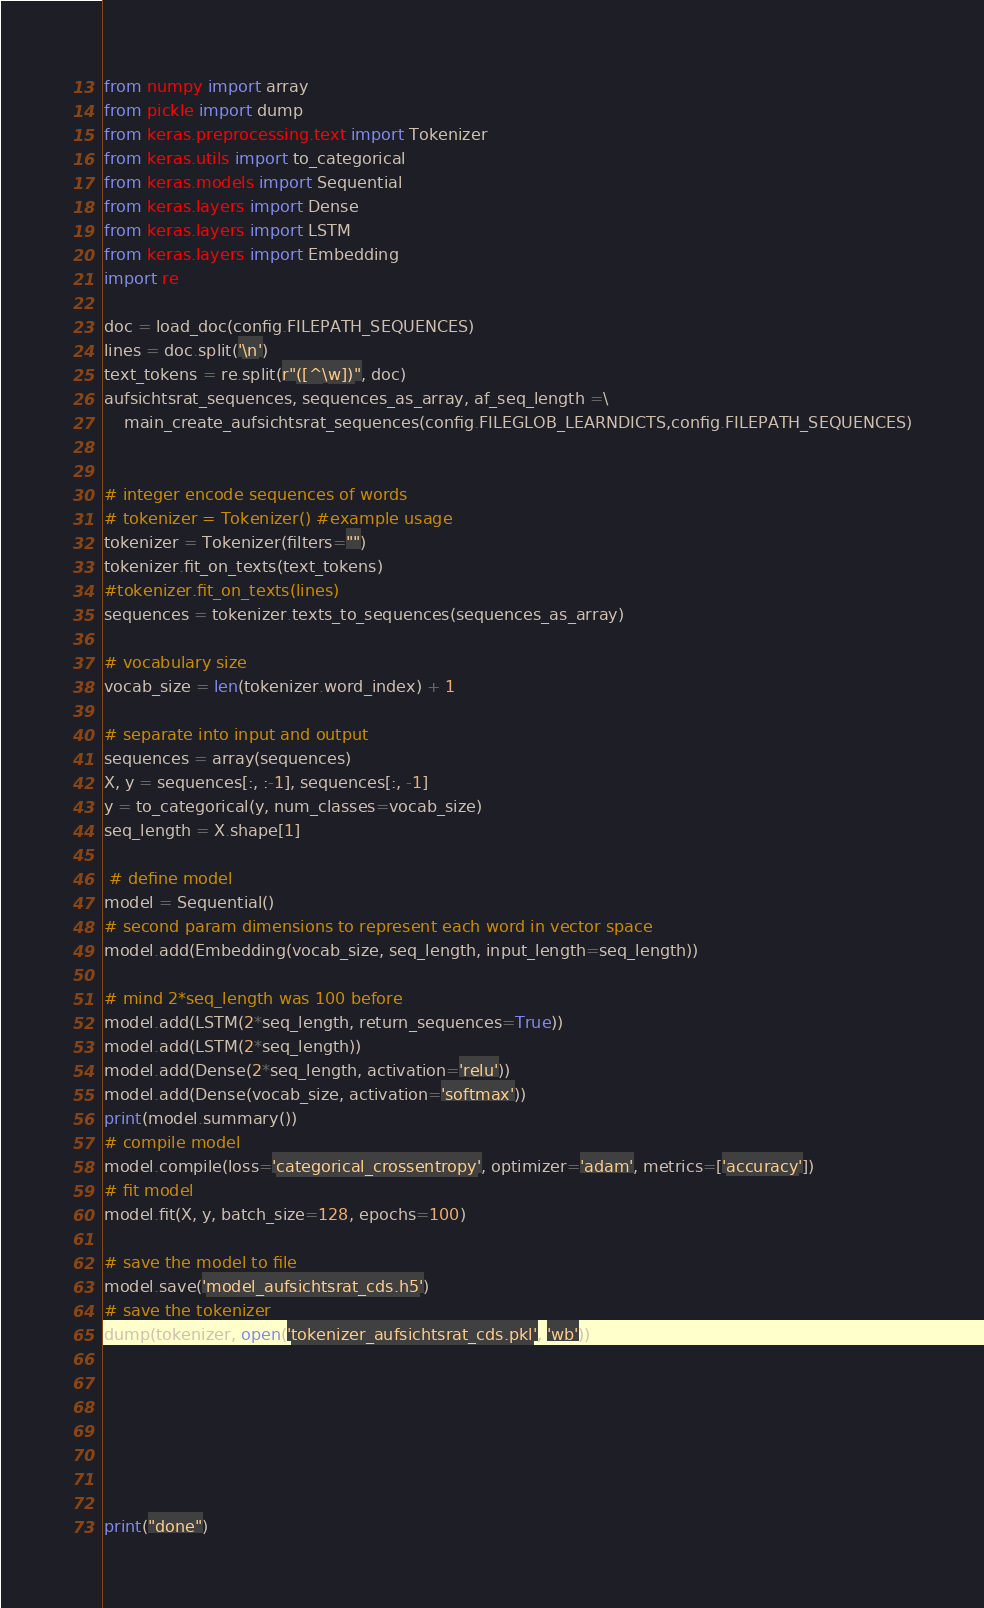<code> <loc_0><loc_0><loc_500><loc_500><_Python_>
from numpy import array
from pickle import dump
from keras.preprocessing.text import Tokenizer
from keras.utils import to_categorical
from keras.models import Sequential
from keras.layers import Dense
from keras.layers import LSTM
from keras.layers import Embedding
import re

doc = load_doc(config.FILEPATH_SEQUENCES)
lines = doc.split('\n')
text_tokens = re.split(r"([^\w])", doc)
aufsichtsrat_sequences, sequences_as_array, af_seq_length =\
    main_create_aufsichtsrat_sequences(config.FILEGLOB_LEARNDICTS,config.FILEPATH_SEQUENCES)


# integer encode sequences of words
# tokenizer = Tokenizer() #example usage
tokenizer = Tokenizer(filters="")
tokenizer.fit_on_texts(text_tokens)
#tokenizer.fit_on_texts(lines)
sequences = tokenizer.texts_to_sequences(sequences_as_array)

# vocabulary size
vocab_size = len(tokenizer.word_index) + 1

# separate into input and output
sequences = array(sequences)
X, y = sequences[:, :-1], sequences[:, -1]
y = to_categorical(y, num_classes=vocab_size)
seq_length = X.shape[1]

 # define model
model = Sequential()
# second param dimensions to represent each word in vector space
model.add(Embedding(vocab_size, seq_length, input_length=seq_length))

# mind 2*seq_length was 100 before
model.add(LSTM(2*seq_length, return_sequences=True))
model.add(LSTM(2*seq_length))
model.add(Dense(2*seq_length, activation='relu'))
model.add(Dense(vocab_size, activation='softmax'))
print(model.summary())
# compile model
model.compile(loss='categorical_crossentropy', optimizer='adam', metrics=['accuracy'])
# fit model
model.fit(X, y, batch_size=128, epochs=100)

# save the model to file
model.save('model_aufsichtsrat_cds.h5')
# save the tokenizer
dump(tokenizer, open('tokenizer_aufsichtsrat_cds.pkl', 'wb'))







print("done")
</code> 